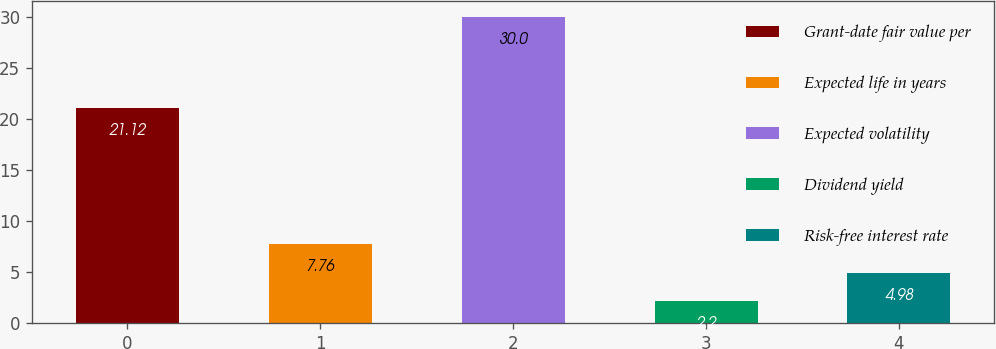Convert chart to OTSL. <chart><loc_0><loc_0><loc_500><loc_500><bar_chart><fcel>Grant-date fair value per<fcel>Expected life in years<fcel>Expected volatility<fcel>Dividend yield<fcel>Risk-free interest rate<nl><fcel>21.12<fcel>7.76<fcel>30<fcel>2.2<fcel>4.98<nl></chart> 